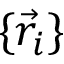Convert formula to latex. <formula><loc_0><loc_0><loc_500><loc_500>\{ \vec { r } _ { i } \}</formula> 